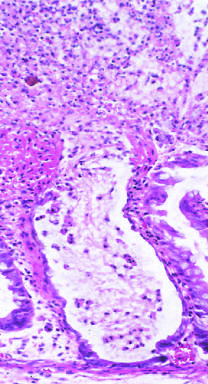s the normal media for comparison reminiscent of a volcanic eruption?
Answer the question using a single word or phrase. No 